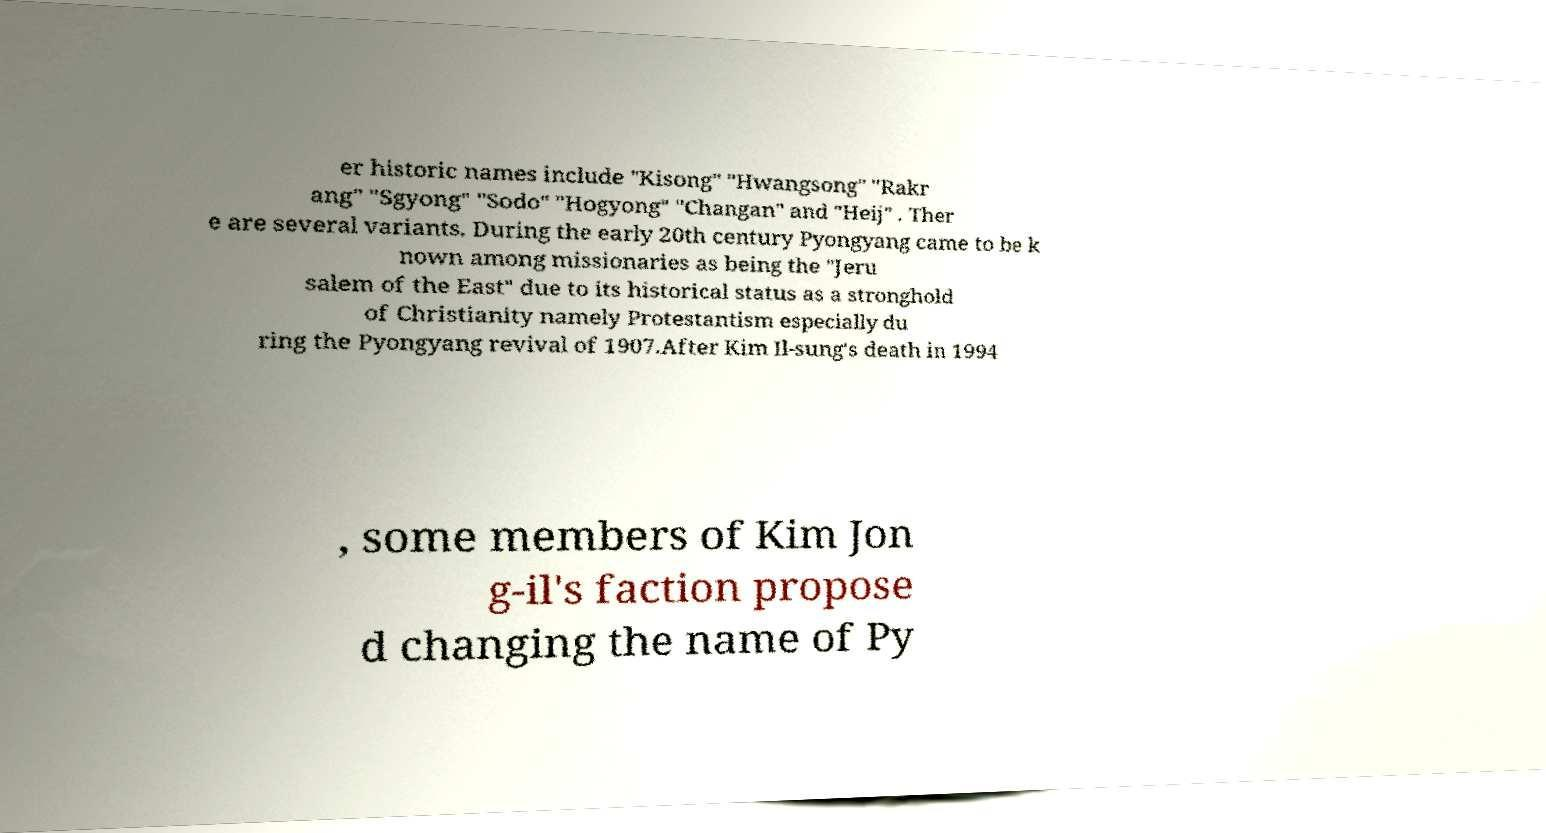Could you extract and type out the text from this image? er historic names include "Kisong" "Hwangsong" "Rakr ang" "Sgyong" "Sodo" "Hogyong" "Changan" and "Heij" . Ther e are several variants. During the early 20th century Pyongyang came to be k nown among missionaries as being the "Jeru salem of the East" due to its historical status as a stronghold of Christianity namely Protestantism especially du ring the Pyongyang revival of 1907.After Kim Il-sung's death in 1994 , some members of Kim Jon g-il's faction propose d changing the name of Py 